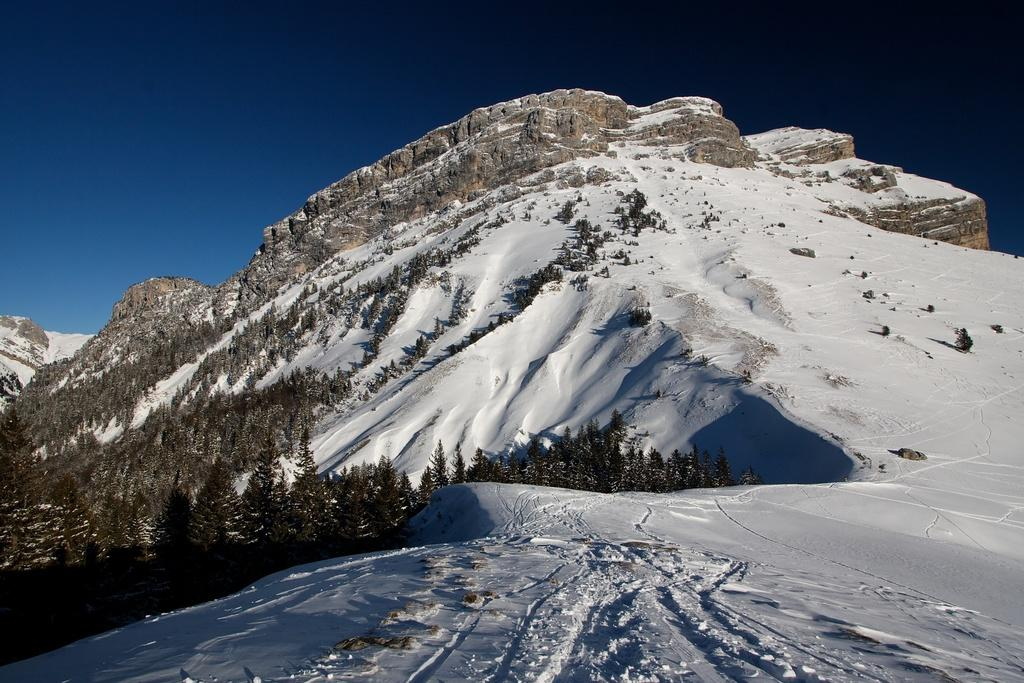What type of natural formation can be seen in the image? There are mountains in the image. What is located in the foreground of the image? There is a group of trees and snow in the foreground. What is visible at the top of the image? The sky is visible at the top of the image. How would you describe the sky in the image? The sky appears to be clear in the image. How many chairs are visible in the image? There are no chairs present in the image. What is the temper of the mountains in the image? The mountains do not have a temper; they are inanimate objects. 